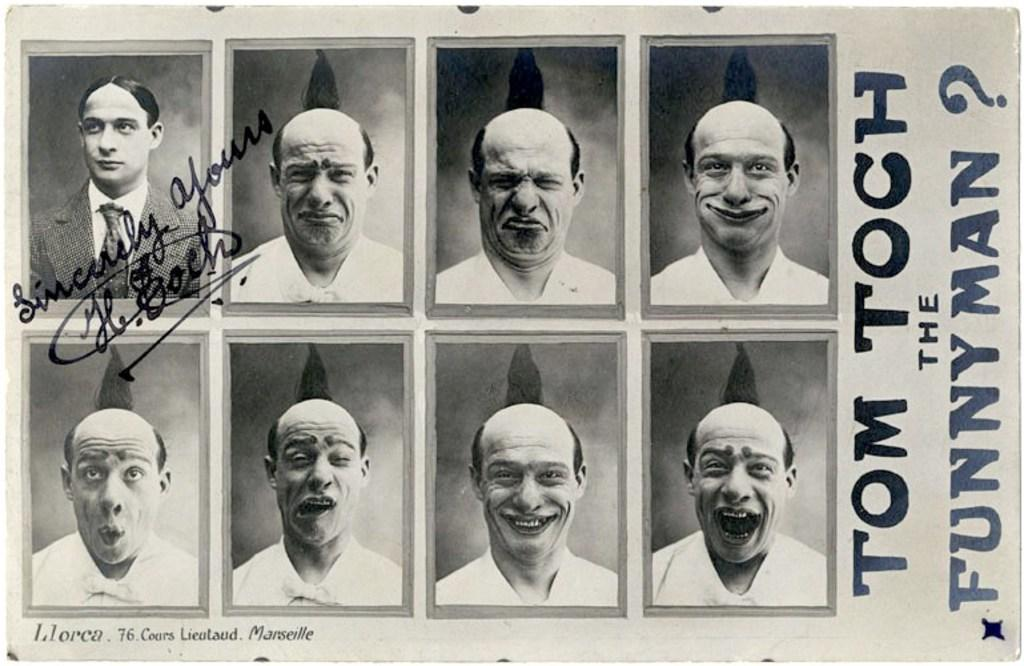What is the main object in the image? There is a paper in the image. What can be seen on the paper? The paper contains images of persons and text. How many spiders are crawling on the paper in the image? There are no spiders present on the paper in the image. What stage of development can be observed on the paper in the image? The paper does not depict any development stages; it contains images of persons and text. 